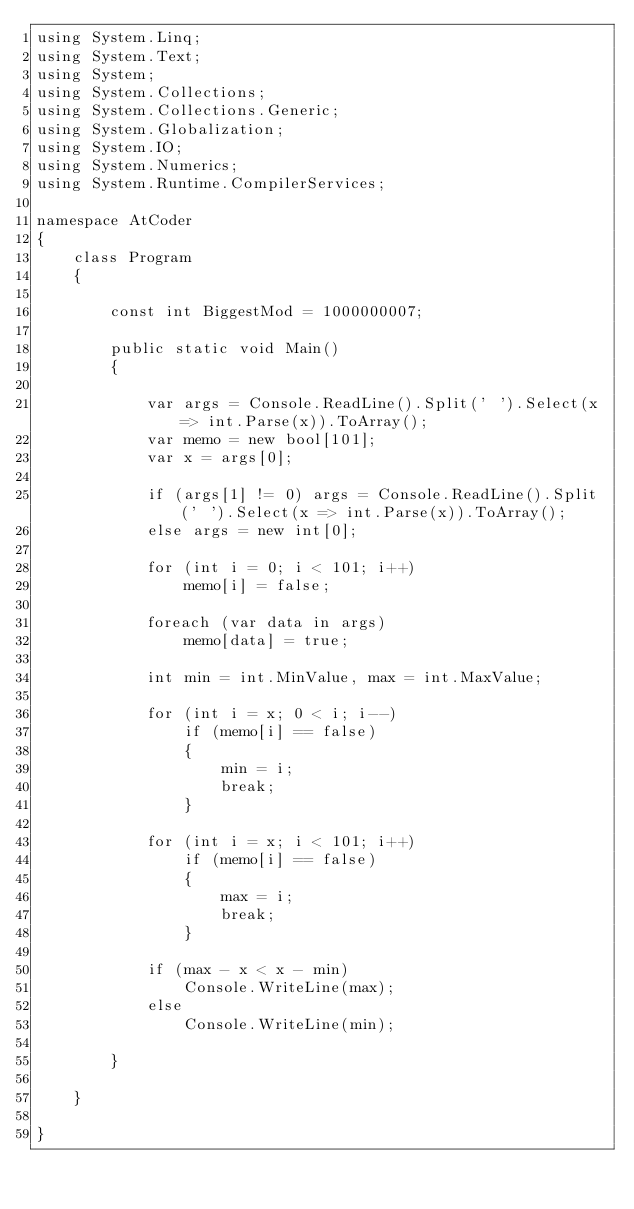Convert code to text. <code><loc_0><loc_0><loc_500><loc_500><_C#_>using System.Linq;
using System.Text;
using System;
using System.Collections;
using System.Collections.Generic;
using System.Globalization;
using System.IO;
using System.Numerics;
using System.Runtime.CompilerServices;

namespace AtCoder
{
    class Program
    {

        const int BiggestMod = 1000000007;

        public static void Main()
        {

            var args = Console.ReadLine().Split(' ').Select(x => int.Parse(x)).ToArray();
            var memo = new bool[101];
            var x = args[0];

            if (args[1] != 0) args = Console.ReadLine().Split(' ').Select(x => int.Parse(x)).ToArray();
            else args = new int[0];

            for (int i = 0; i < 101; i++)
                memo[i] = false;

            foreach (var data in args)
                memo[data] = true;

            int min = int.MinValue, max = int.MaxValue;

            for (int i = x; 0 < i; i--)
                if (memo[i] == false)
                {
                    min = i;
                    break;
                }

            for (int i = x; i < 101; i++)
                if (memo[i] == false)
                {
                    max = i;
                    break;
                }

            if (max - x < x - min)
                Console.WriteLine(max);
            else
                Console.WriteLine(min);

        }

    }

}
</code> 